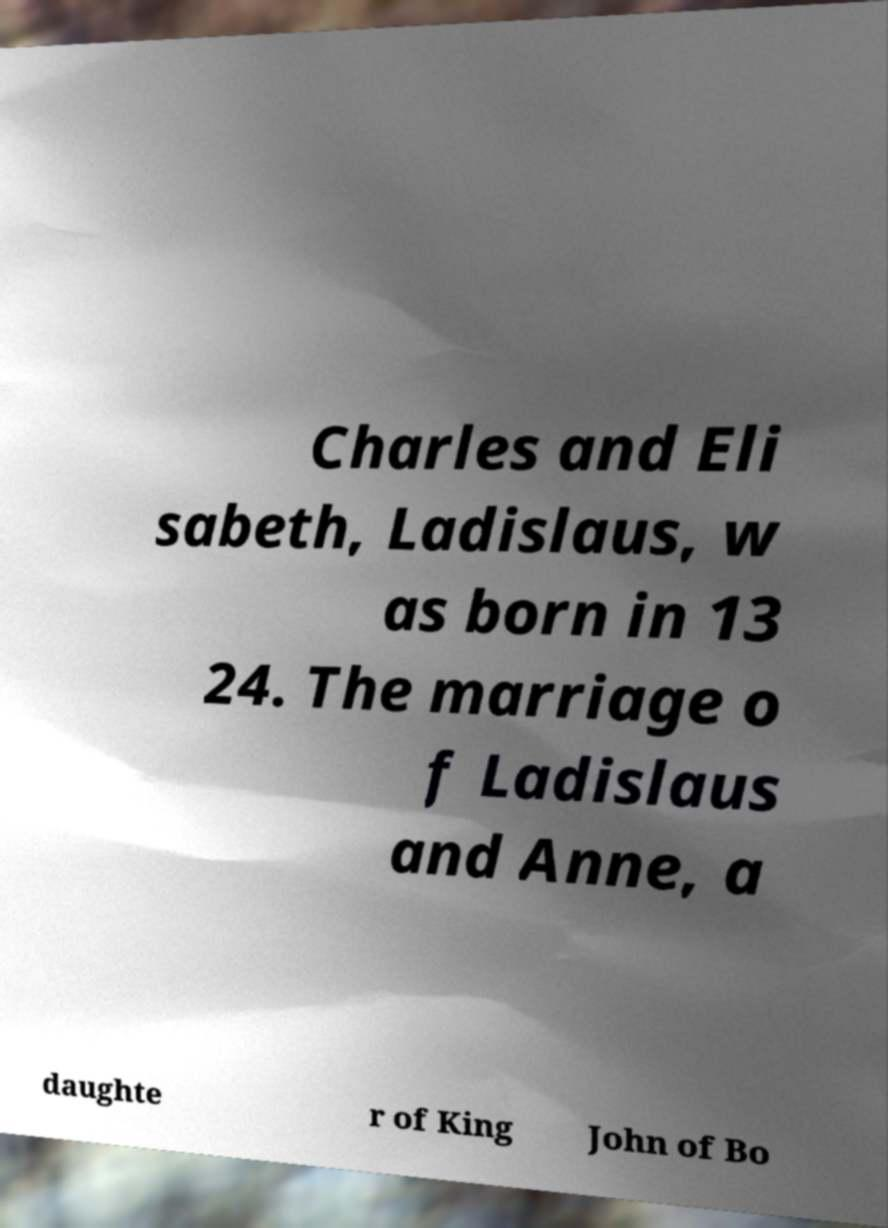What messages or text are displayed in this image? I need them in a readable, typed format. Charles and Eli sabeth, Ladislaus, w as born in 13 24. The marriage o f Ladislaus and Anne, a daughte r of King John of Bo 